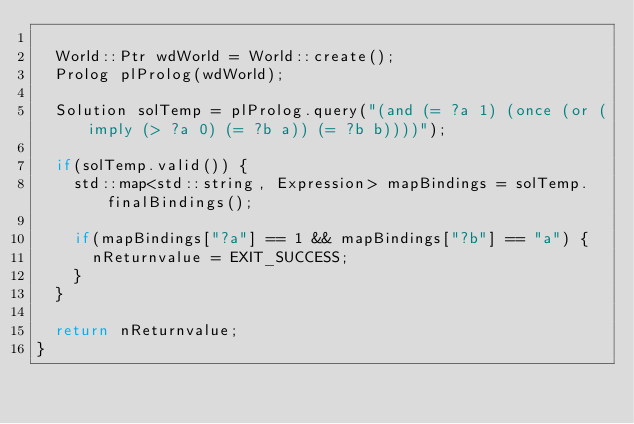<code> <loc_0><loc_0><loc_500><loc_500><_C++_>  
  World::Ptr wdWorld = World::create();
  Prolog plProlog(wdWorld);
  
  Solution solTemp = plProlog.query("(and (= ?a 1) (once (or (imply (> ?a 0) (= ?b a)) (= ?b b))))");
  
  if(solTemp.valid()) {
    std::map<std::string, Expression> mapBindings = solTemp.finalBindings();
    
    if(mapBindings["?a"] == 1 && mapBindings["?b"] == "a") {
      nReturnvalue = EXIT_SUCCESS;
    }
  }
  
  return nReturnvalue;
}
</code> 